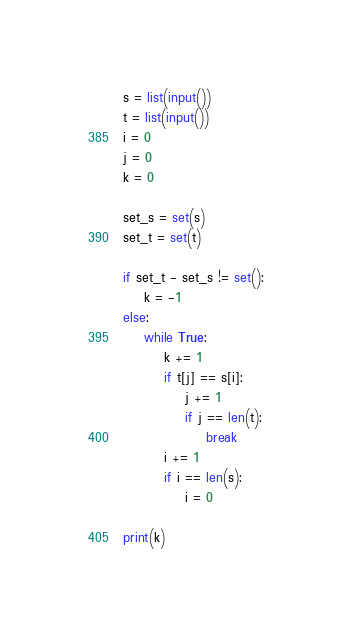Convert code to text. <code><loc_0><loc_0><loc_500><loc_500><_Python_>s = list(input())
t = list(input())
i = 0
j = 0
k = 0

set_s = set(s)
set_t = set(t)

if set_t - set_s != set():
    k = -1
else:
    while True:
        k += 1
        if t[j] == s[i]:
            j += 1
            if j == len(t):
                break
        i += 1
        if i == len(s):
            i = 0

print(k)
</code> 